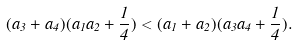Convert formula to latex. <formula><loc_0><loc_0><loc_500><loc_500>( a _ { 3 } + a _ { 4 } ) ( a _ { 1 } a _ { 2 } + \frac { 1 } { 4 } ) < ( a _ { 1 } + a _ { 2 } ) ( a _ { 3 } a _ { 4 } + \frac { 1 } { 4 } ) .</formula> 